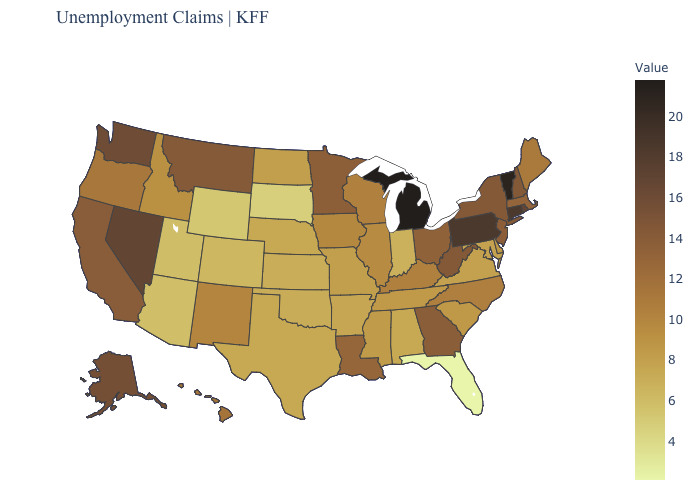Among the states that border Utah , does Nevada have the highest value?
Give a very brief answer. Yes. Does Arizona have a lower value than Florida?
Quick response, please. No. Which states have the lowest value in the MidWest?
Quick response, please. South Dakota. Does Michigan have the highest value in the USA?
Write a very short answer. Yes. Which states have the highest value in the USA?
Write a very short answer. Michigan. Which states hav the highest value in the Northeast?
Short answer required. Vermont. 